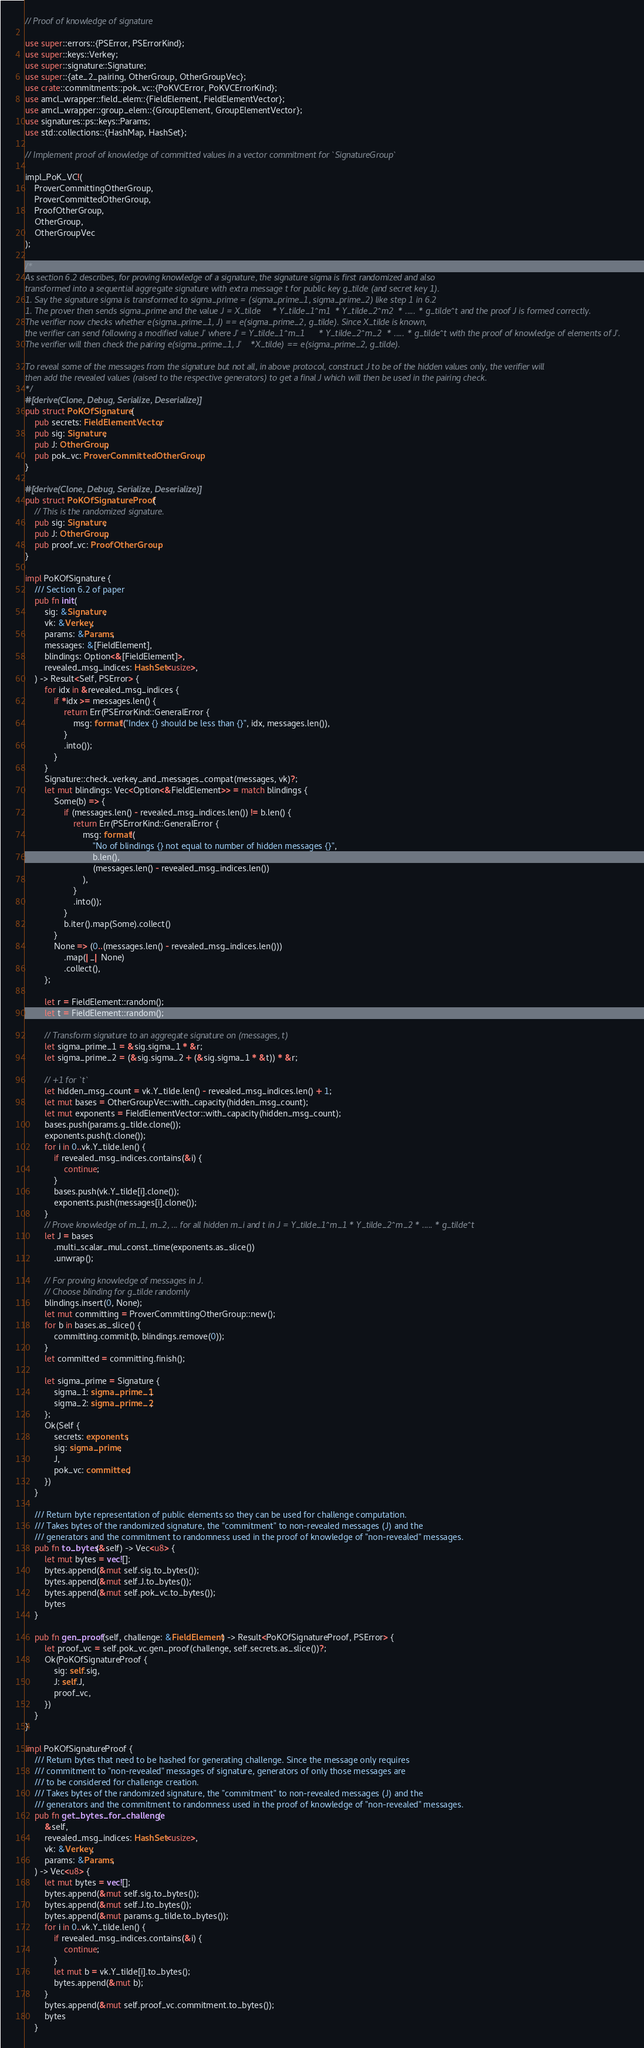Convert code to text. <code><loc_0><loc_0><loc_500><loc_500><_Rust_>// Proof of knowledge of signature

use super::errors::{PSError, PSErrorKind};
use super::keys::Verkey;
use super::signature::Signature;
use super::{ate_2_pairing, OtherGroup, OtherGroupVec};
use crate::commitments::pok_vc::{PoKVCError, PoKVCErrorKind};
use amcl_wrapper::field_elem::{FieldElement, FieldElementVector};
use amcl_wrapper::group_elem::{GroupElement, GroupElementVector};
use signatures::ps::keys::Params;
use std::collections::{HashMap, HashSet};

// Implement proof of knowledge of committed values in a vector commitment for `SignatureGroup`

impl_PoK_VC!(
    ProverCommittingOtherGroup,
    ProverCommittedOtherGroup,
    ProofOtherGroup,
    OtherGroup,
    OtherGroupVec
);

/*
As section 6.2 describes, for proving knowledge of a signature, the signature sigma is first randomized and also
transformed into a sequential aggregate signature with extra message t for public key g_tilde (and secret key 1).
1. Say the signature sigma is transformed to sigma_prime = (sigma_prime_1, sigma_prime_2) like step 1 in 6.2
1. The prover then sends sigma_prime and the value J = X_tilde * Y_tilde_1^m1 * Y_tilde_2^m2 * ..... * g_tilde^t and the proof J is formed correctly.
The verifier now checks whether e(sigma_prime_1, J) == e(sigma_prime_2, g_tilde). Since X_tilde is known,
the verifier can send following a modified value J' where J' = Y_tilde_1^m_1 * Y_tilde_2^m_2 * ..... * g_tilde^t with the proof of knowledge of elements of J'.
The verifier will then check the pairing e(sigma_prime_1, J'*X_tilde) == e(sigma_prime_2, g_tilde).

To reveal some of the messages from the signature but not all, in above protocol, construct J to be of the hidden values only, the verifier will
then add the revealed values (raised to the respective generators) to get a final J which will then be used in the pairing check.
*/
#[derive(Clone, Debug, Serialize, Deserialize)]
pub struct PoKOfSignature {
    pub secrets: FieldElementVector,
    pub sig: Signature,
    pub J: OtherGroup,
    pub pok_vc: ProverCommittedOtherGroup,
}

#[derive(Clone, Debug, Serialize, Deserialize)]
pub struct PoKOfSignatureProof {
    // This is the randomized signature.
    pub sig: Signature,
    pub J: OtherGroup,
    pub proof_vc: ProofOtherGroup,
}

impl PoKOfSignature {
    /// Section 6.2 of paper
    pub fn init(
        sig: &Signature,
        vk: &Verkey,
        params: &Params,
        messages: &[FieldElement],
        blindings: Option<&[FieldElement]>,
        revealed_msg_indices: HashSet<usize>,
    ) -> Result<Self, PSError> {
        for idx in &revealed_msg_indices {
            if *idx >= messages.len() {
                return Err(PSErrorKind::GeneralError {
                    msg: format!("Index {} should be less than {}", idx, messages.len()),
                }
                .into());
            }
        }
        Signature::check_verkey_and_messages_compat(messages, vk)?;
        let mut blindings: Vec<Option<&FieldElement>> = match blindings {
            Some(b) => {
                if (messages.len() - revealed_msg_indices.len()) != b.len() {
                    return Err(PSErrorKind::GeneralError {
                        msg: format!(
                            "No of blindings {} not equal to number of hidden messages {}",
                            b.len(),
                            (messages.len() - revealed_msg_indices.len())
                        ),
                    }
                    .into());
                }
                b.iter().map(Some).collect()
            }
            None => (0..(messages.len() - revealed_msg_indices.len()))
                .map(|_| None)
                .collect(),
        };

        let r = FieldElement::random();
        let t = FieldElement::random();

        // Transform signature to an aggregate signature on (messages, t)
        let sigma_prime_1 = &sig.sigma_1 * &r;
        let sigma_prime_2 = (&sig.sigma_2 + (&sig.sigma_1 * &t)) * &r;

        // +1 for `t`
        let hidden_msg_count = vk.Y_tilde.len() - revealed_msg_indices.len() + 1;
        let mut bases = OtherGroupVec::with_capacity(hidden_msg_count);
        let mut exponents = FieldElementVector::with_capacity(hidden_msg_count);
        bases.push(params.g_tilde.clone());
        exponents.push(t.clone());
        for i in 0..vk.Y_tilde.len() {
            if revealed_msg_indices.contains(&i) {
                continue;
            }
            bases.push(vk.Y_tilde[i].clone());
            exponents.push(messages[i].clone());
        }
        // Prove knowledge of m_1, m_2, ... for all hidden m_i and t in J = Y_tilde_1^m_1 * Y_tilde_2^m_2 * ..... * g_tilde^t
        let J = bases
            .multi_scalar_mul_const_time(exponents.as_slice())
            .unwrap();

        // For proving knowledge of messages in J.
        // Choose blinding for g_tilde randomly
        blindings.insert(0, None);
        let mut committing = ProverCommittingOtherGroup::new();
        for b in bases.as_slice() {
            committing.commit(b, blindings.remove(0));
        }
        let committed = committing.finish();

        let sigma_prime = Signature {
            sigma_1: sigma_prime_1,
            sigma_2: sigma_prime_2,
        };
        Ok(Self {
            secrets: exponents,
            sig: sigma_prime,
            J,
            pok_vc: committed,
        })
    }

    /// Return byte representation of public elements so they can be used for challenge computation.
    /// Takes bytes of the randomized signature, the "commitment" to non-revealed messages (J) and the
    /// generators and the commitment to randomness used in the proof of knowledge of "non-revealed" messages.
    pub fn to_bytes(&self) -> Vec<u8> {
        let mut bytes = vec![];
        bytes.append(&mut self.sig.to_bytes());
        bytes.append(&mut self.J.to_bytes());
        bytes.append(&mut self.pok_vc.to_bytes());
        bytes
    }

    pub fn gen_proof(self, challenge: &FieldElement) -> Result<PoKOfSignatureProof, PSError> {
        let proof_vc = self.pok_vc.gen_proof(challenge, self.secrets.as_slice())?;
        Ok(PoKOfSignatureProof {
            sig: self.sig,
            J: self.J,
            proof_vc,
        })
    }
}

impl PoKOfSignatureProof {
    /// Return bytes that need to be hashed for generating challenge. Since the message only requires
    /// commitment to "non-revealed" messages of signature, generators of only those messages are
    /// to be considered for challenge creation.
    /// Takes bytes of the randomized signature, the "commitment" to non-revealed messages (J) and the
    /// generators and the commitment to randomness used in the proof of knowledge of "non-revealed" messages.
    pub fn get_bytes_for_challenge(
        &self,
        revealed_msg_indices: HashSet<usize>,
        vk: &Verkey,
        params: &Params,
    ) -> Vec<u8> {
        let mut bytes = vec![];
        bytes.append(&mut self.sig.to_bytes());
        bytes.append(&mut self.J.to_bytes());
        bytes.append(&mut params.g_tilde.to_bytes());
        for i in 0..vk.Y_tilde.len() {
            if revealed_msg_indices.contains(&i) {
                continue;
            }
            let mut b = vk.Y_tilde[i].to_bytes();
            bytes.append(&mut b);
        }
        bytes.append(&mut self.proof_vc.commitment.to_bytes());
        bytes
    }
</code> 